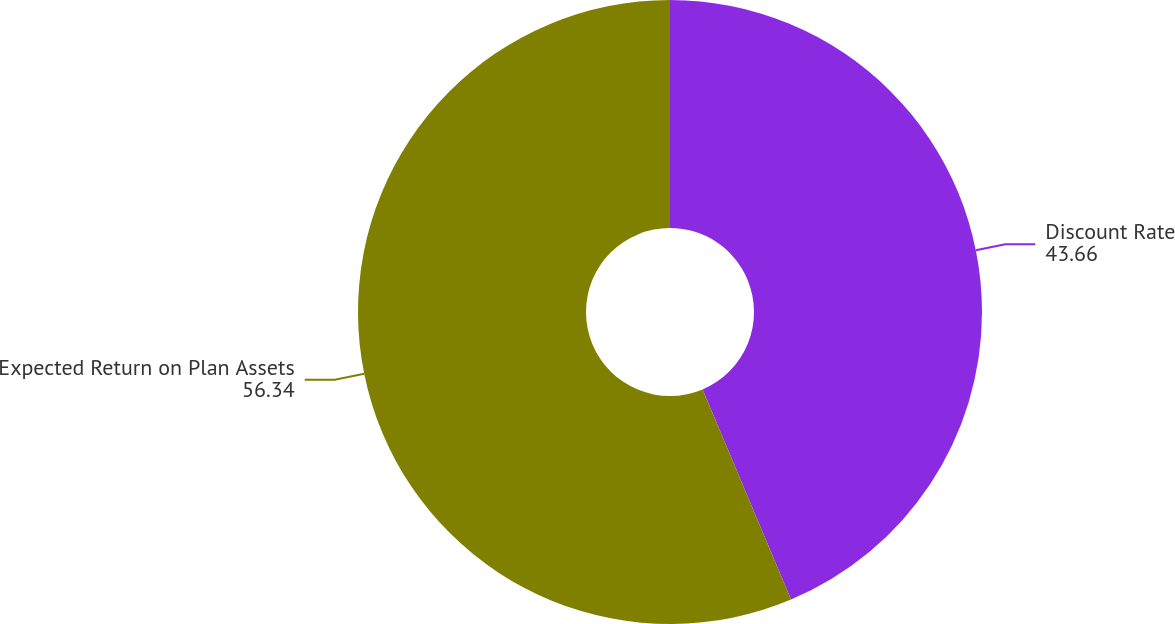Convert chart. <chart><loc_0><loc_0><loc_500><loc_500><pie_chart><fcel>Discount Rate<fcel>Expected Return on Plan Assets<nl><fcel>43.66%<fcel>56.34%<nl></chart> 